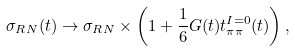Convert formula to latex. <formula><loc_0><loc_0><loc_500><loc_500>\sigma _ { R N } ( t ) \rightarrow \sigma _ { R N } \times \left ( 1 + \frac { 1 } { 6 } G ( t ) t _ { \pi \pi } ^ { I = 0 } ( t ) \right ) ,</formula> 